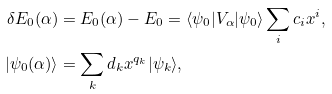<formula> <loc_0><loc_0><loc_500><loc_500>\delta E _ { 0 } ( \alpha ) & = E _ { 0 } ( \alpha ) - E _ { 0 } = \langle \psi _ { 0 } | V _ { \alpha } | \psi _ { 0 } \rangle \sum _ { i } c _ { i } x ^ { i } , \\ | \psi _ { 0 } ( \alpha ) \rangle & = \sum _ { k } d _ { k } x ^ { q _ { k } } | \psi _ { k } \rangle ,</formula> 